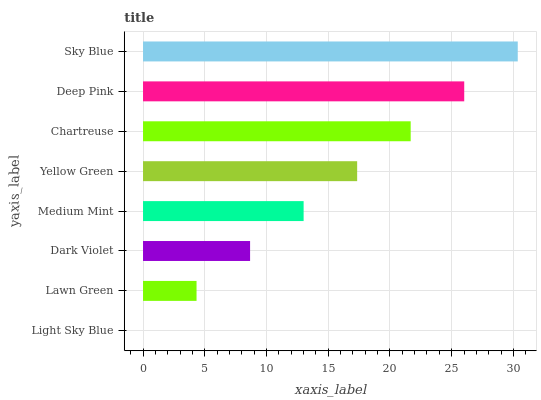Is Light Sky Blue the minimum?
Answer yes or no. Yes. Is Sky Blue the maximum?
Answer yes or no. Yes. Is Lawn Green the minimum?
Answer yes or no. No. Is Lawn Green the maximum?
Answer yes or no. No. Is Lawn Green greater than Light Sky Blue?
Answer yes or no. Yes. Is Light Sky Blue less than Lawn Green?
Answer yes or no. Yes. Is Light Sky Blue greater than Lawn Green?
Answer yes or no. No. Is Lawn Green less than Light Sky Blue?
Answer yes or no. No. Is Yellow Green the high median?
Answer yes or no. Yes. Is Medium Mint the low median?
Answer yes or no. Yes. Is Lawn Green the high median?
Answer yes or no. No. Is Sky Blue the low median?
Answer yes or no. No. 